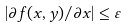Convert formula to latex. <formula><loc_0><loc_0><loc_500><loc_500>| \partial f ( x , y ) / \partial x | \leq \varepsilon</formula> 